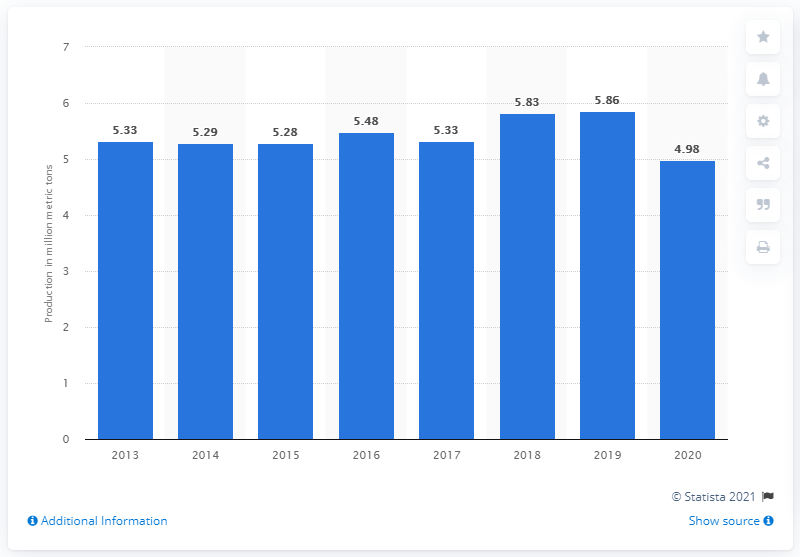Highlight a few significant elements in this photo. In 2020, a total of 4.98 million liters of gasoline was produced in Malaysia. 